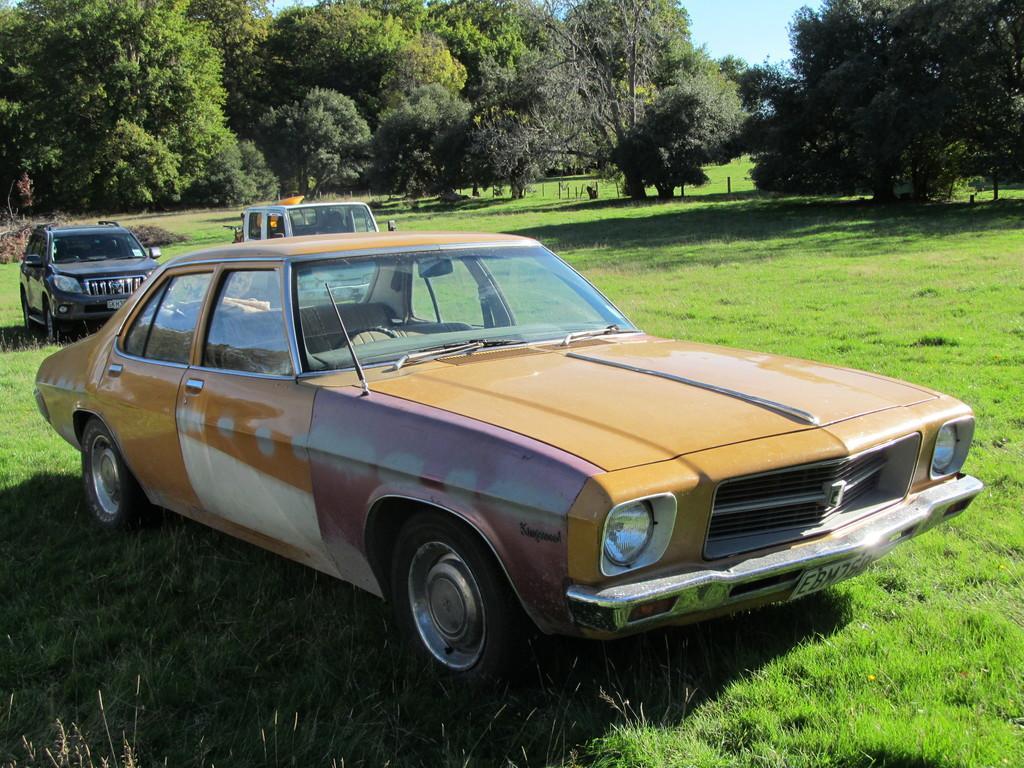Can you describe this image briefly? In this image we can see some cars placed on the ground. We can also see some grass, poles, a group of trees and the sky which looks cloudy. 